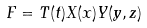<formula> <loc_0><loc_0><loc_500><loc_500>F = T ( t ) X ( x ) Y ( y , z )</formula> 